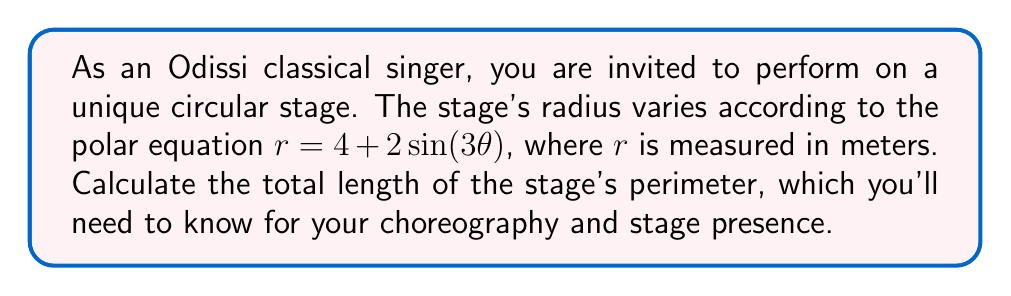Solve this math problem. To find the length of the stage's perimeter, we need to use polar integration. The formula for the arc length in polar coordinates is:

$$L = \int_0^{2\pi} \sqrt{r^2 + \left(\frac{dr}{d\theta}\right)^2} d\theta$$

Let's break this down step-by-step:

1) First, we need to find $\frac{dr}{d\theta}$:
   $r = 4 + 2\sin(3\theta)$
   $\frac{dr}{d\theta} = 6\cos(3\theta)$

2) Now, let's substitute these into the formula:
   $$L = \int_0^{2\pi} \sqrt{(4 + 2\sin(3\theta))^2 + (6\cos(3\theta))^2} d\theta$$

3) Simplify inside the square root:
   $$L = \int_0^{2\pi} \sqrt{16 + 16\sin(3\theta) + 4\sin^2(3\theta) + 36\cos^2(3\theta)} d\theta$$

4) Use the identity $\sin^2(x) + \cos^2(x) = 1$:
   $$L = \int_0^{2\pi} \sqrt{16 + 16\sin(3\theta) + 4 + 32\cos^2(3\theta)} d\theta$$
   $$L = \int_0^{2\pi} \sqrt{20 + 16\sin(3\theta) + 32\cos^2(3\theta)} d\theta$$

5) This integral cannot be solved analytically. We need to use numerical integration methods to approximate the result.

6) Using a numerical integration tool or computer algebra system, we can evaluate this integral.

[asy]
import graph;
size(200);
real r(real t) {return 4+2*sin(3t);}
path g=polargraph(r,0,2pi,300);
draw(g);
draw(circle((0,0),4));
label("$r=4+2\sin(3\theta)$", (5,5), E);
[/asy]

The result of the numerical integration is approximately 27.3185 meters.
Answer: The length of the stage's perimeter is approximately 27.32 meters. 